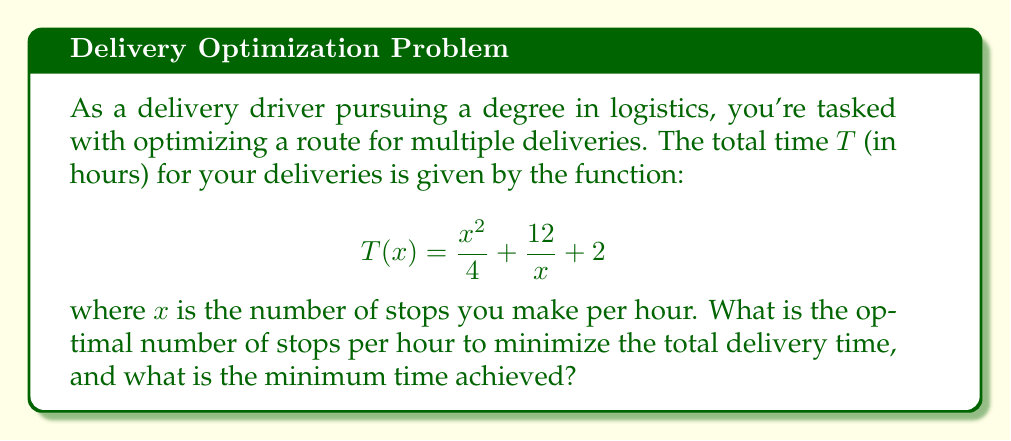Help me with this question. To find the optimal number of stops per hour that minimizes the total delivery time, we need to find the minimum of the function $T(x)$. We can do this by following these steps:

1) First, we need to find the derivative of $T(x)$:
   $$T'(x) = \frac{d}{dx}\left(\frac{x^2}{4} + \frac{12}{x} + 2\right)$$
   $$T'(x) = \frac{2x}{4} - \frac{12}{x^2}$$
   $$T'(x) = \frac{x}{2} - \frac{12}{x^2}$$

2) To find the minimum, we set $T'(x) = 0$ and solve for $x$:
   $$\frac{x}{2} - \frac{12}{x^2} = 0$$
   $$\frac{x^3}{2} = 12$$
   $$x^3 = 24$$
   $$x = \sqrt[3]{24} = 2\sqrt[3]{3}$$

3) To confirm this is a minimum, we can check the second derivative:
   $$T''(x) = \frac{1}{2} + \frac{24}{x^3}$$
   At $x = 2\sqrt[3]{3}$, $T''(x) > 0$, confirming a minimum.

4) Now, we can calculate the minimum time by plugging $x = 2\sqrt[3]{3}$ back into our original function:
   $$T(2\sqrt[3]{3}) = \frac{(2\sqrt[3]{3})^2}{4} + \frac{12}{2\sqrt[3]{3}} + 2$$
   $$= \sqrt[3]{9} + \sqrt[3]{9} + 2$$
   $$= 2\sqrt[3]{9} + 2$$

Therefore, the optimal number of stops per hour is $2\sqrt[3]{3}$ (approximately 2.88 stops), and the minimum time achieved is $2\sqrt[3]{9} + 2$ hours (approximately 5.46 hours).
Answer: Optimal stops: $2\sqrt[3]{3}$ per hour; Minimum time: $2\sqrt[3]{9} + 2$ hours 